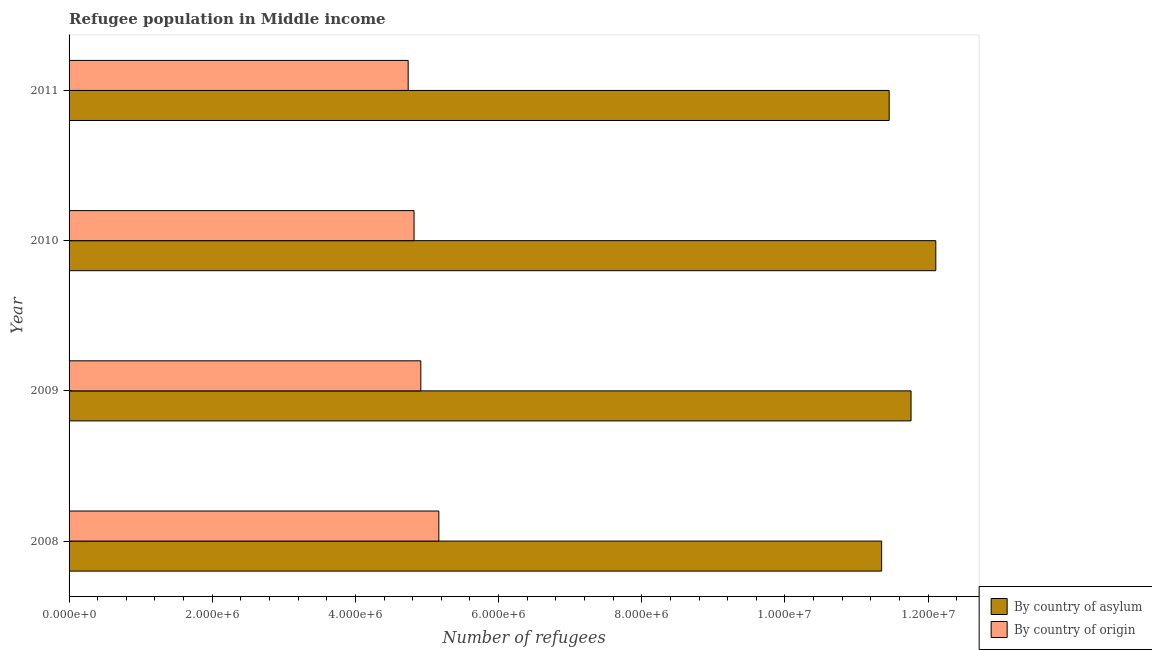How many groups of bars are there?
Your answer should be very brief. 4. Are the number of bars on each tick of the Y-axis equal?
Offer a very short reply. Yes. How many bars are there on the 4th tick from the top?
Give a very brief answer. 2. In how many cases, is the number of bars for a given year not equal to the number of legend labels?
Offer a terse response. 0. What is the number of refugees by country of asylum in 2011?
Make the answer very short. 1.15e+07. Across all years, what is the maximum number of refugees by country of asylum?
Your response must be concise. 1.21e+07. Across all years, what is the minimum number of refugees by country of asylum?
Ensure brevity in your answer.  1.14e+07. In which year was the number of refugees by country of origin maximum?
Provide a succinct answer. 2008. In which year was the number of refugees by country of origin minimum?
Offer a very short reply. 2011. What is the total number of refugees by country of origin in the graph?
Offer a very short reply. 1.96e+07. What is the difference between the number of refugees by country of asylum in 2009 and that in 2010?
Keep it short and to the point. -3.46e+05. What is the difference between the number of refugees by country of asylum in 2011 and the number of refugees by country of origin in 2010?
Make the answer very short. 6.64e+06. What is the average number of refugees by country of asylum per year?
Keep it short and to the point. 1.17e+07. In the year 2008, what is the difference between the number of refugees by country of asylum and number of refugees by country of origin?
Provide a short and direct response. 6.19e+06. In how many years, is the number of refugees by country of origin greater than 10400000 ?
Your response must be concise. 0. Is the difference between the number of refugees by country of asylum in 2009 and 2010 greater than the difference between the number of refugees by country of origin in 2009 and 2010?
Your answer should be very brief. No. What is the difference between the highest and the second highest number of refugees by country of asylum?
Your response must be concise. 3.46e+05. What is the difference between the highest and the lowest number of refugees by country of asylum?
Keep it short and to the point. 7.57e+05. Is the sum of the number of refugees by country of origin in 2008 and 2009 greater than the maximum number of refugees by country of asylum across all years?
Your response must be concise. No. What does the 1st bar from the top in 2008 represents?
Your answer should be compact. By country of origin. What does the 1st bar from the bottom in 2008 represents?
Your answer should be very brief. By country of asylum. Are all the bars in the graph horizontal?
Ensure brevity in your answer.  Yes. How many years are there in the graph?
Provide a succinct answer. 4. What is the difference between two consecutive major ticks on the X-axis?
Your response must be concise. 2.00e+06. Does the graph contain any zero values?
Keep it short and to the point. No. How many legend labels are there?
Offer a terse response. 2. How are the legend labels stacked?
Give a very brief answer. Vertical. What is the title of the graph?
Make the answer very short. Refugee population in Middle income. Does "Number of arrivals" appear as one of the legend labels in the graph?
Your answer should be compact. No. What is the label or title of the X-axis?
Give a very brief answer. Number of refugees. What is the Number of refugees of By country of asylum in 2008?
Give a very brief answer. 1.14e+07. What is the Number of refugees in By country of origin in 2008?
Offer a very short reply. 5.17e+06. What is the Number of refugees of By country of asylum in 2009?
Provide a short and direct response. 1.18e+07. What is the Number of refugees in By country of origin in 2009?
Your response must be concise. 4.91e+06. What is the Number of refugees in By country of asylum in 2010?
Give a very brief answer. 1.21e+07. What is the Number of refugees of By country of origin in 2010?
Ensure brevity in your answer.  4.82e+06. What is the Number of refugees in By country of asylum in 2011?
Make the answer very short. 1.15e+07. What is the Number of refugees in By country of origin in 2011?
Your answer should be compact. 4.74e+06. Across all years, what is the maximum Number of refugees of By country of asylum?
Your answer should be compact. 1.21e+07. Across all years, what is the maximum Number of refugees of By country of origin?
Provide a succinct answer. 5.17e+06. Across all years, what is the minimum Number of refugees in By country of asylum?
Ensure brevity in your answer.  1.14e+07. Across all years, what is the minimum Number of refugees in By country of origin?
Ensure brevity in your answer.  4.74e+06. What is the total Number of refugees in By country of asylum in the graph?
Provide a succinct answer. 4.67e+07. What is the total Number of refugees of By country of origin in the graph?
Ensure brevity in your answer.  1.96e+07. What is the difference between the Number of refugees of By country of asylum in 2008 and that in 2009?
Provide a succinct answer. -4.11e+05. What is the difference between the Number of refugees of By country of origin in 2008 and that in 2009?
Your answer should be very brief. 2.52e+05. What is the difference between the Number of refugees in By country of asylum in 2008 and that in 2010?
Your answer should be very brief. -7.57e+05. What is the difference between the Number of refugees in By country of origin in 2008 and that in 2010?
Offer a terse response. 3.46e+05. What is the difference between the Number of refugees of By country of asylum in 2008 and that in 2011?
Your answer should be compact. -1.06e+05. What is the difference between the Number of refugees in By country of origin in 2008 and that in 2011?
Give a very brief answer. 4.28e+05. What is the difference between the Number of refugees of By country of asylum in 2009 and that in 2010?
Offer a terse response. -3.46e+05. What is the difference between the Number of refugees of By country of origin in 2009 and that in 2010?
Your answer should be very brief. 9.43e+04. What is the difference between the Number of refugees of By country of asylum in 2009 and that in 2011?
Keep it short and to the point. 3.05e+05. What is the difference between the Number of refugees in By country of origin in 2009 and that in 2011?
Your response must be concise. 1.76e+05. What is the difference between the Number of refugees of By country of asylum in 2010 and that in 2011?
Give a very brief answer. 6.51e+05. What is the difference between the Number of refugees of By country of origin in 2010 and that in 2011?
Make the answer very short. 8.22e+04. What is the difference between the Number of refugees in By country of asylum in 2008 and the Number of refugees in By country of origin in 2009?
Make the answer very short. 6.44e+06. What is the difference between the Number of refugees of By country of asylum in 2008 and the Number of refugees of By country of origin in 2010?
Your answer should be very brief. 6.53e+06. What is the difference between the Number of refugees in By country of asylum in 2008 and the Number of refugees in By country of origin in 2011?
Your response must be concise. 6.61e+06. What is the difference between the Number of refugees of By country of asylum in 2009 and the Number of refugees of By country of origin in 2010?
Offer a terse response. 6.94e+06. What is the difference between the Number of refugees of By country of asylum in 2009 and the Number of refugees of By country of origin in 2011?
Ensure brevity in your answer.  7.02e+06. What is the difference between the Number of refugees in By country of asylum in 2010 and the Number of refugees in By country of origin in 2011?
Your answer should be compact. 7.37e+06. What is the average Number of refugees in By country of asylum per year?
Your answer should be compact. 1.17e+07. What is the average Number of refugees of By country of origin per year?
Provide a short and direct response. 4.91e+06. In the year 2008, what is the difference between the Number of refugees in By country of asylum and Number of refugees in By country of origin?
Give a very brief answer. 6.19e+06. In the year 2009, what is the difference between the Number of refugees of By country of asylum and Number of refugees of By country of origin?
Provide a succinct answer. 6.85e+06. In the year 2010, what is the difference between the Number of refugees in By country of asylum and Number of refugees in By country of origin?
Your answer should be very brief. 7.29e+06. In the year 2011, what is the difference between the Number of refugees in By country of asylum and Number of refugees in By country of origin?
Your response must be concise. 6.72e+06. What is the ratio of the Number of refugees in By country of asylum in 2008 to that in 2009?
Your answer should be compact. 0.97. What is the ratio of the Number of refugees in By country of origin in 2008 to that in 2009?
Provide a succinct answer. 1.05. What is the ratio of the Number of refugees in By country of origin in 2008 to that in 2010?
Your answer should be very brief. 1.07. What is the ratio of the Number of refugees of By country of origin in 2008 to that in 2011?
Your answer should be compact. 1.09. What is the ratio of the Number of refugees of By country of asylum in 2009 to that in 2010?
Give a very brief answer. 0.97. What is the ratio of the Number of refugees in By country of origin in 2009 to that in 2010?
Your answer should be compact. 1.02. What is the ratio of the Number of refugees in By country of asylum in 2009 to that in 2011?
Your answer should be compact. 1.03. What is the ratio of the Number of refugees in By country of origin in 2009 to that in 2011?
Offer a very short reply. 1.04. What is the ratio of the Number of refugees in By country of asylum in 2010 to that in 2011?
Offer a very short reply. 1.06. What is the ratio of the Number of refugees in By country of origin in 2010 to that in 2011?
Provide a succinct answer. 1.02. What is the difference between the highest and the second highest Number of refugees of By country of asylum?
Make the answer very short. 3.46e+05. What is the difference between the highest and the second highest Number of refugees in By country of origin?
Keep it short and to the point. 2.52e+05. What is the difference between the highest and the lowest Number of refugees in By country of asylum?
Make the answer very short. 7.57e+05. What is the difference between the highest and the lowest Number of refugees of By country of origin?
Provide a succinct answer. 4.28e+05. 